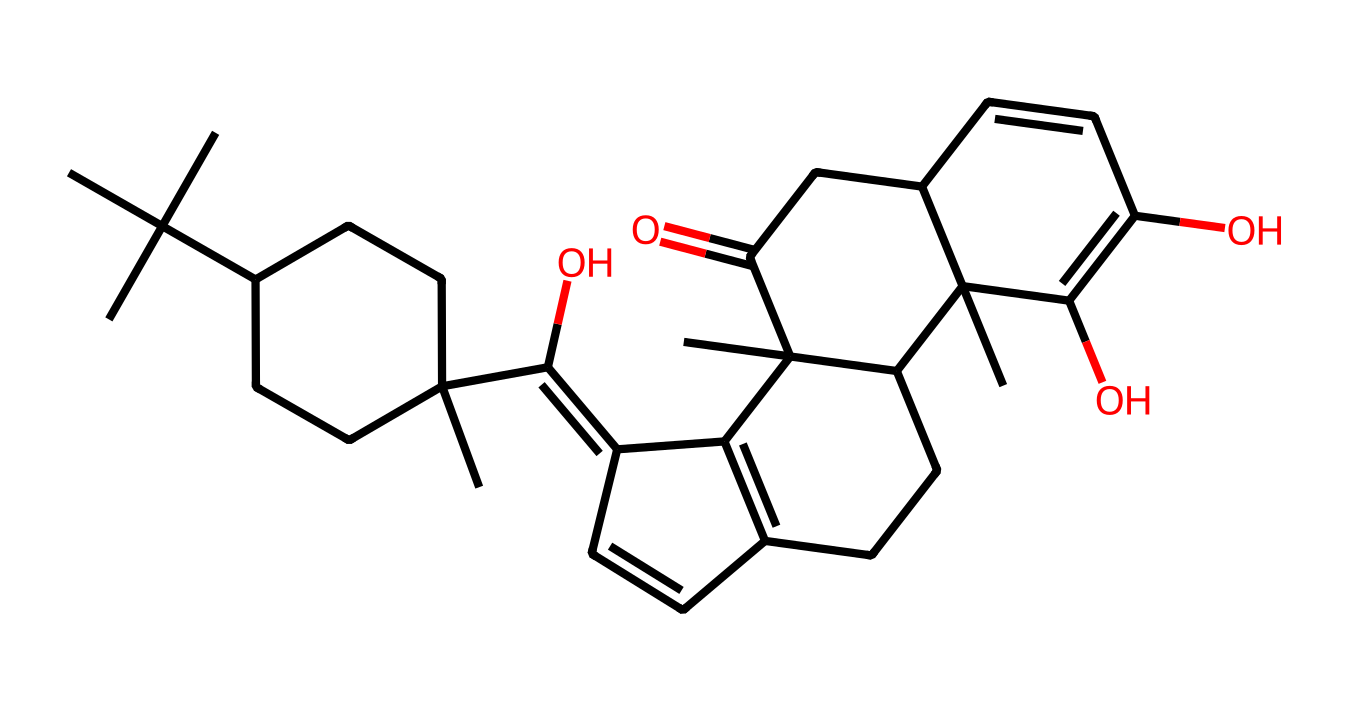What is the name of this chemical? The SMILES representation corresponds to cannabidiol, a well-known non-psychoactive cannabinoid found in cannabis. The structure depicted implies a complex arrangement of carbon and other atoms.
Answer: cannabidiol How many rings are present in this chemical structure? By analyzing the cyclic sections of the SMILES string, we can identify at least two distinct cyclical carbon structures within the representation. This indicates the presence of two rings in the molecule.
Answer: two What is the degree of unsaturation in this molecule? The number of double bonds and rings contributes to the degree of unsaturation, which can be calculated by the formula: (number of carbon atoms - number of hydrogen atoms + 2). Analyzing the given SMILES shows a specific number of each which leads to a suitable unsaturation value.
Answer: five What functional groups are present in this chemical? The analysis of the chemical structure suggests the presence of hydroxyl (-OH) groups. Specifically, it can be seen that there are two such groups linked to the carbon framework, making them the identified functional groups in the compound.
Answer: hydroxyl groups Is cannabidiol a cyclic compound? A cyclic compound is characterized by the presence of one or more rings in its structure. The visual interpretation of this SMILES representation confirms the presence of cyclical carbon arrangements, thus, it can be classified as cyclic.
Answer: yes What type of bonds can be observed in the structure of cannabidiol? Looking closely at the connectivity in the SMILES, it reveals a mixture of single, double bonds, and cyclic structures inherent in the compound's carbon backbone. This diverse bonding structure is a characteristic aspect of cannabidiol's architecture.
Answer: single and double bonds 